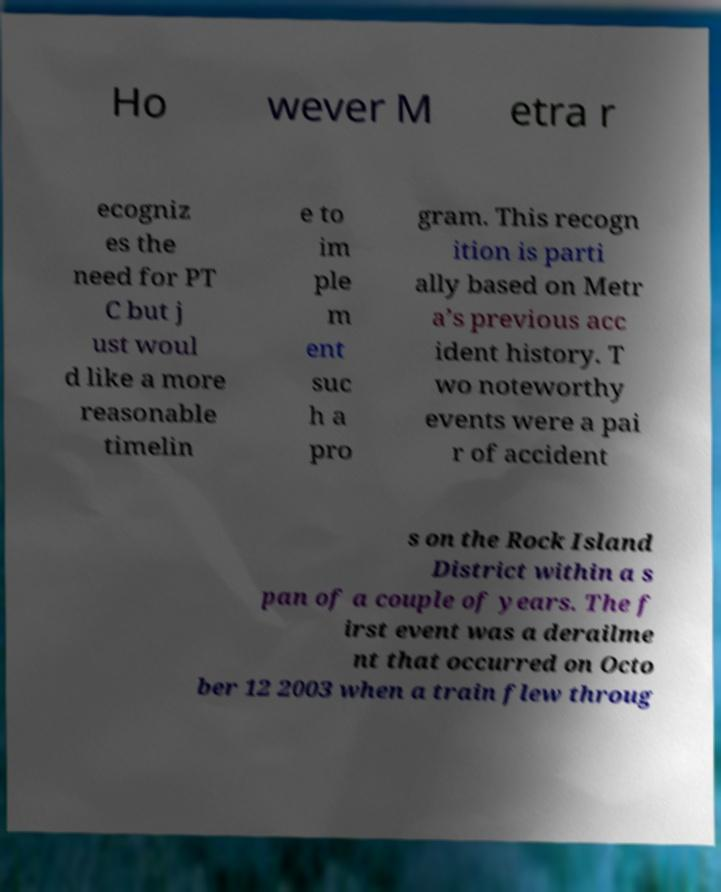Can you read and provide the text displayed in the image?This photo seems to have some interesting text. Can you extract and type it out for me? Ho wever M etra r ecogniz es the need for PT C but j ust woul d like a more reasonable timelin e to im ple m ent suc h a pro gram. This recogn ition is parti ally based on Metr a’s previous acc ident history. T wo noteworthy events were a pai r of accident s on the Rock Island District within a s pan of a couple of years. The f irst event was a derailme nt that occurred on Octo ber 12 2003 when a train flew throug 